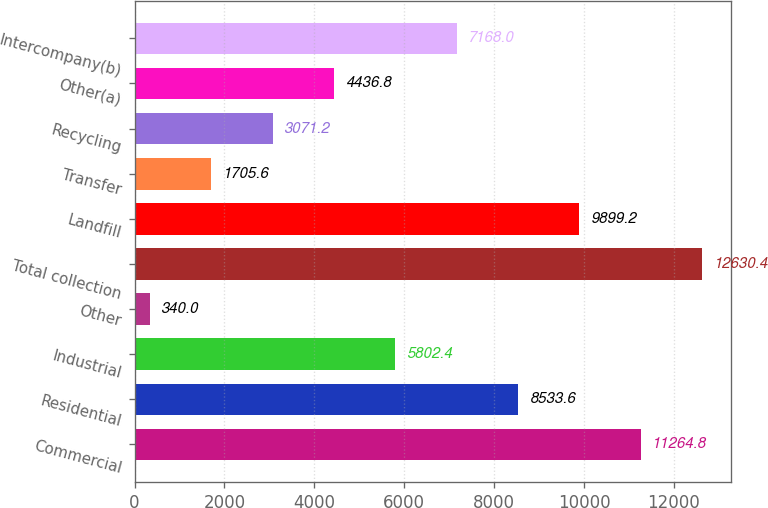Convert chart to OTSL. <chart><loc_0><loc_0><loc_500><loc_500><bar_chart><fcel>Commercial<fcel>Residential<fcel>Industrial<fcel>Other<fcel>Total collection<fcel>Landfill<fcel>Transfer<fcel>Recycling<fcel>Other(a)<fcel>Intercompany(b)<nl><fcel>11264.8<fcel>8533.6<fcel>5802.4<fcel>340<fcel>12630.4<fcel>9899.2<fcel>1705.6<fcel>3071.2<fcel>4436.8<fcel>7168<nl></chart> 